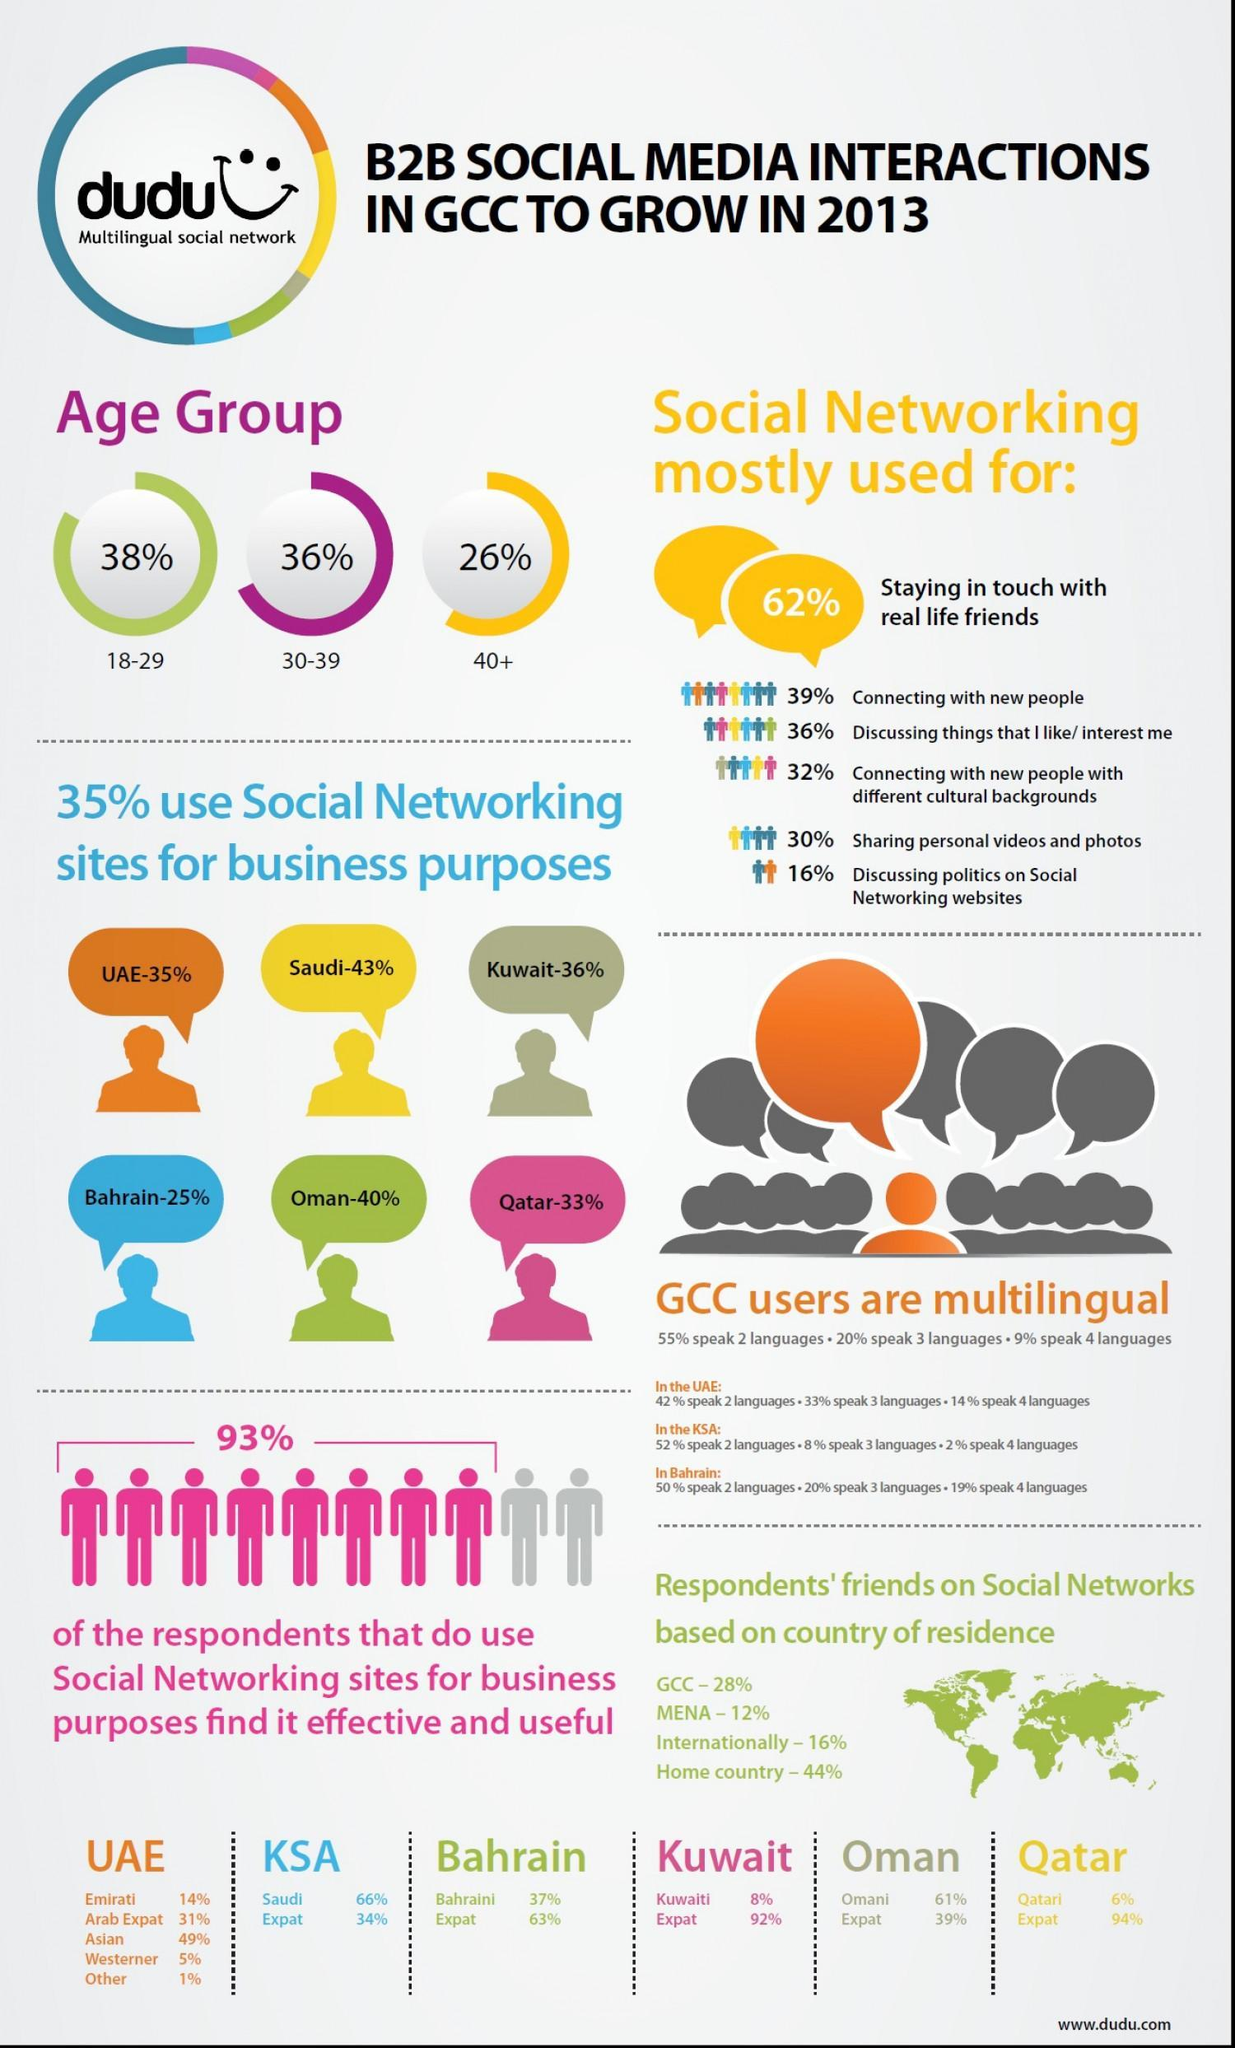What percentage of people use social networking in the age group 18-39?
Answer the question with a short phrase. 74% How many more people in the age group 18-29 use social networking than people aged 30-39? 2% Countries from which continent are represented in the infographic, Asia or Africa? Asia How many more people in the age group 30-39 use social networking than people aged 40+? 10% 